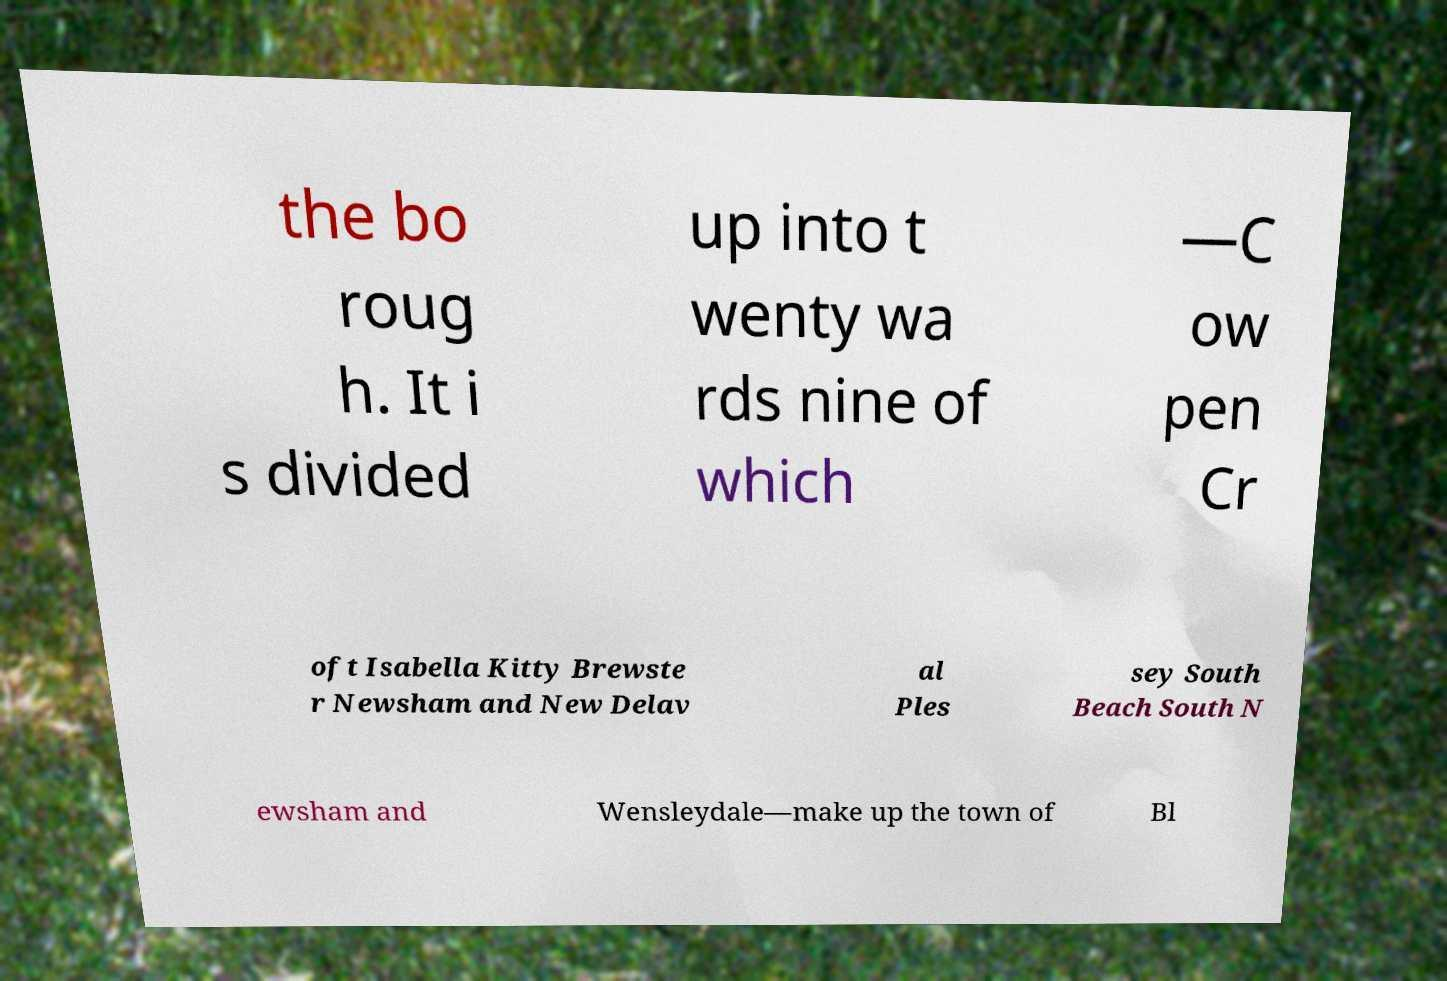What messages or text are displayed in this image? I need them in a readable, typed format. the bo roug h. It i s divided up into t wenty wa rds nine of which —C ow pen Cr oft Isabella Kitty Brewste r Newsham and New Delav al Ples sey South Beach South N ewsham and Wensleydale—make up the town of Bl 